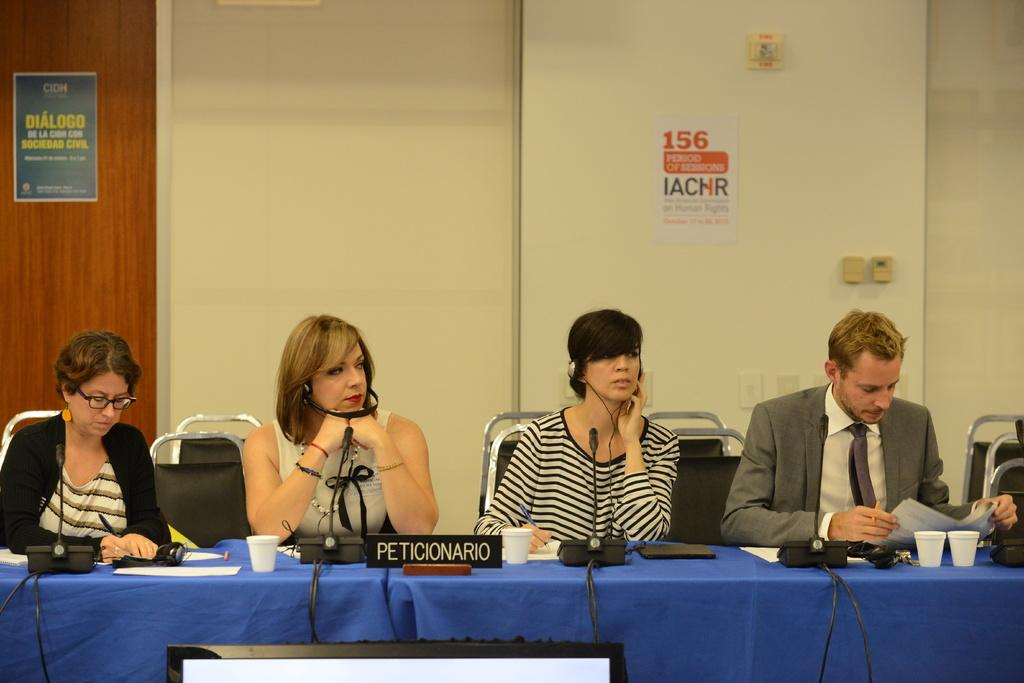What type of room is shown in the image? The image depicts a meeting room. What color is the table in the room? There is a blue color table in the room. How many people are present in the room? Four people are sitting at the table. What is located behind the people? There is a door and a wall behind the people. What is attached to the wall? There is a poster stick on the wall. What type of sheet is covering the throat of the person sitting at the table? There is no sheet covering the throat of any person in the image. 